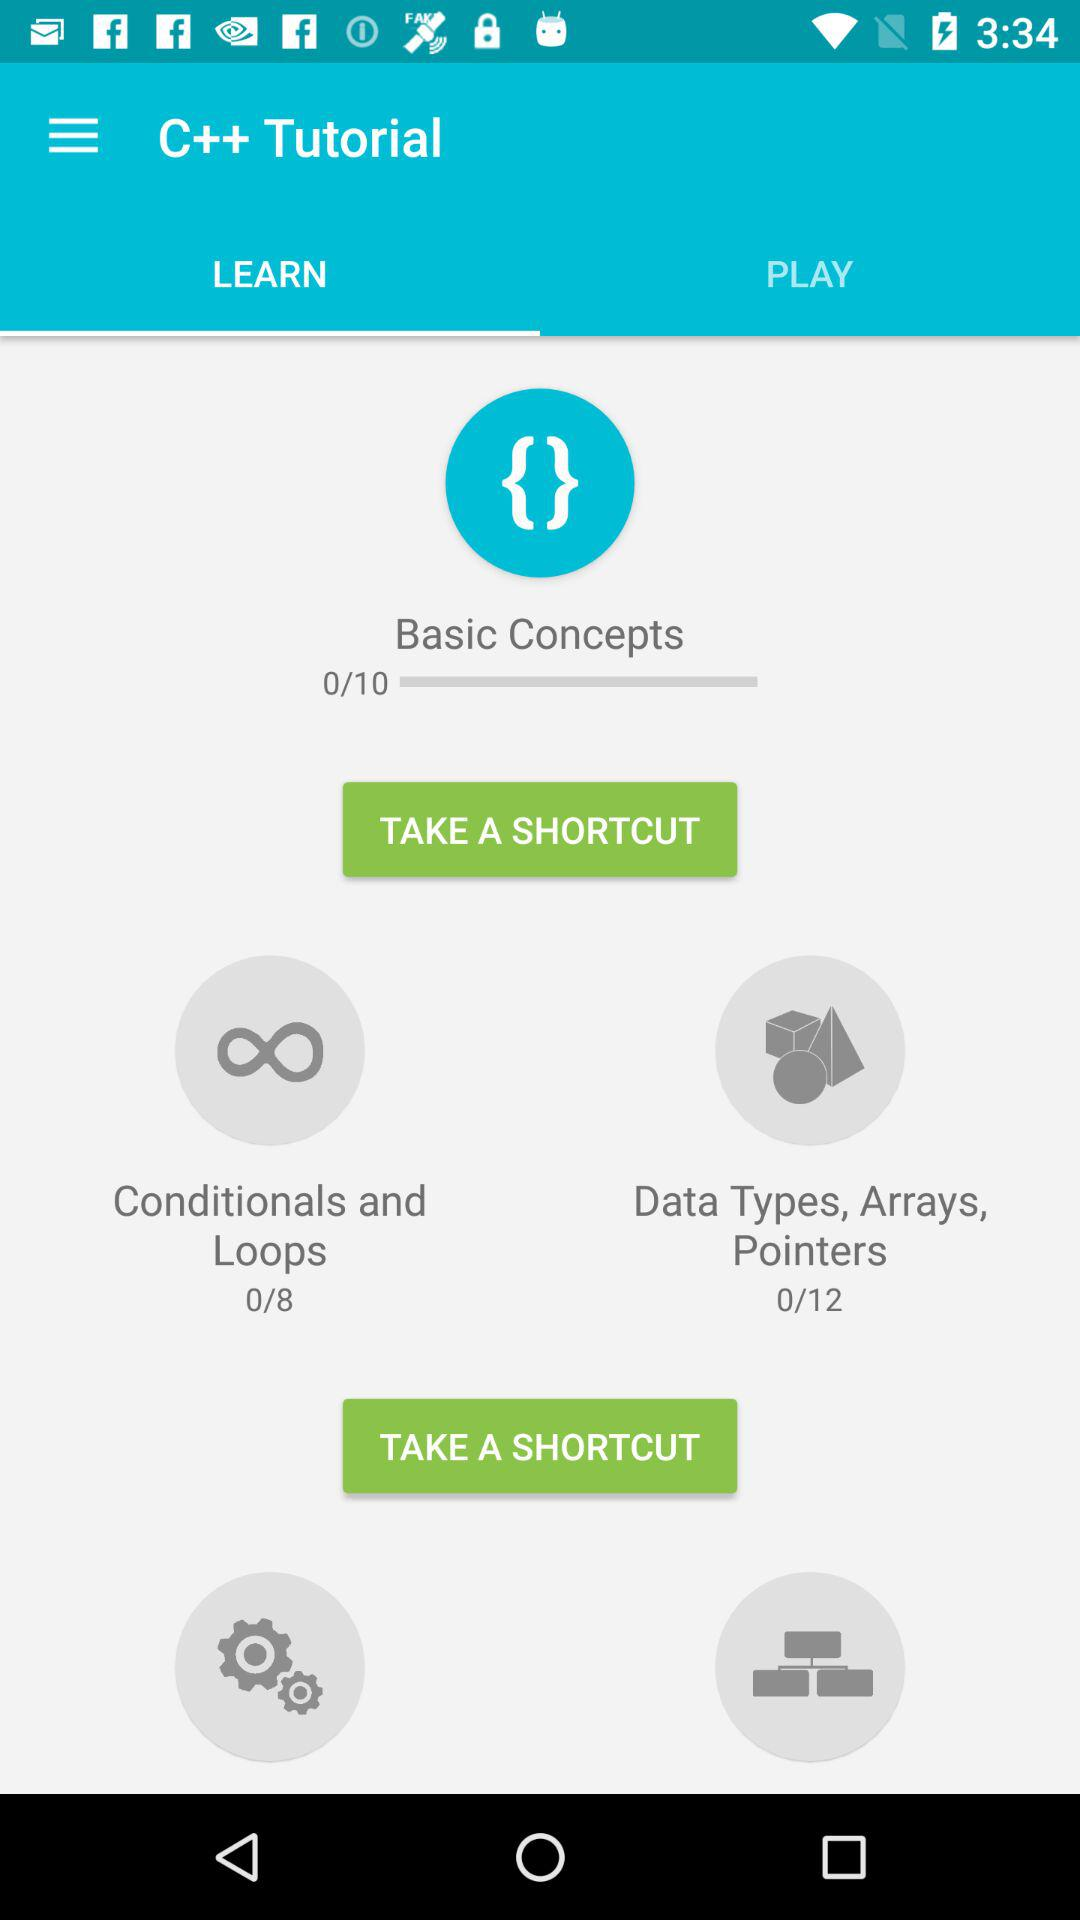What is the app name? The app name is "C++ Tutorial". 